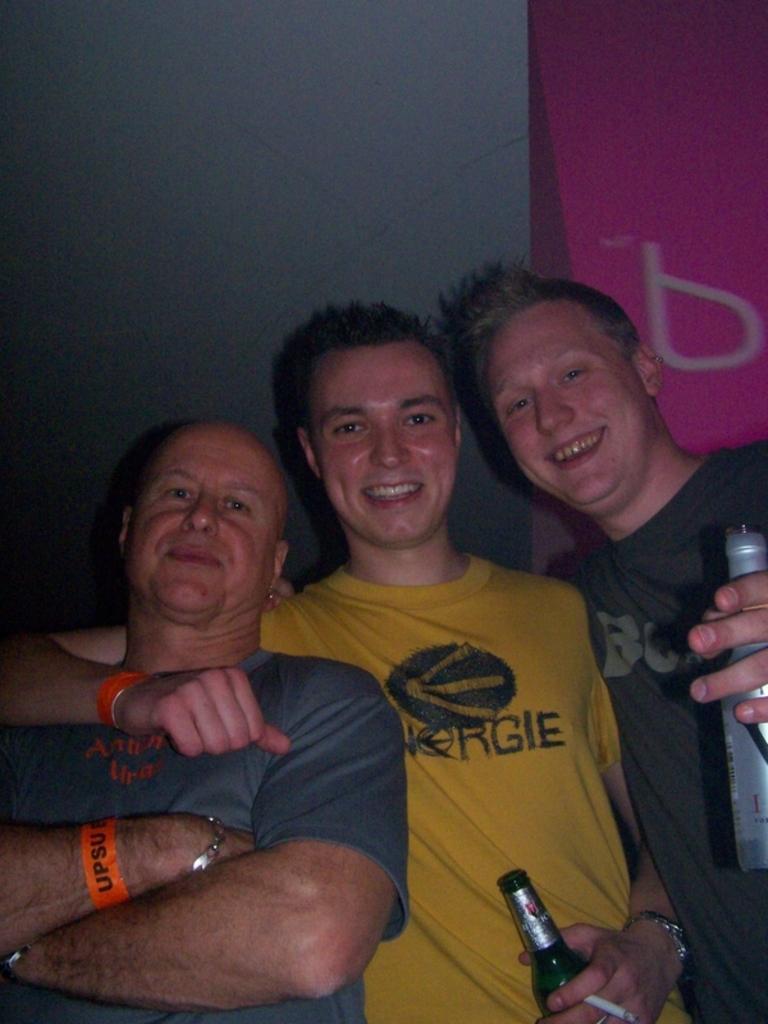Describe this image in one or two sentences. This image is clicked inside. There are three men in this image. In the man wearing yellow t-shirt is holding bottle. To the left, the man wearing black t-shirt is standing and smiling. In the background, there is wall along with wallpaper. 